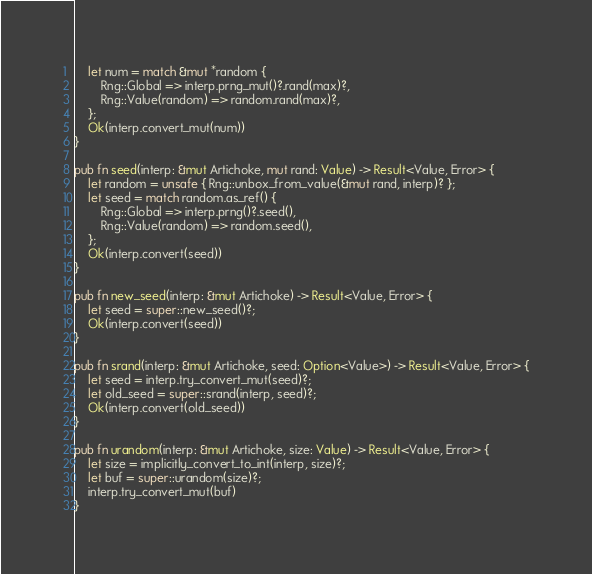<code> <loc_0><loc_0><loc_500><loc_500><_Rust_>    let num = match &mut *random {
        Rng::Global => interp.prng_mut()?.rand(max)?,
        Rng::Value(random) => random.rand(max)?,
    };
    Ok(interp.convert_mut(num))
}

pub fn seed(interp: &mut Artichoke, mut rand: Value) -> Result<Value, Error> {
    let random = unsafe { Rng::unbox_from_value(&mut rand, interp)? };
    let seed = match random.as_ref() {
        Rng::Global => interp.prng()?.seed(),
        Rng::Value(random) => random.seed(),
    };
    Ok(interp.convert(seed))
}

pub fn new_seed(interp: &mut Artichoke) -> Result<Value, Error> {
    let seed = super::new_seed()?;
    Ok(interp.convert(seed))
}

pub fn srand(interp: &mut Artichoke, seed: Option<Value>) -> Result<Value, Error> {
    let seed = interp.try_convert_mut(seed)?;
    let old_seed = super::srand(interp, seed)?;
    Ok(interp.convert(old_seed))
}

pub fn urandom(interp: &mut Artichoke, size: Value) -> Result<Value, Error> {
    let size = implicitly_convert_to_int(interp, size)?;
    let buf = super::urandom(size)?;
    interp.try_convert_mut(buf)
}
</code> 